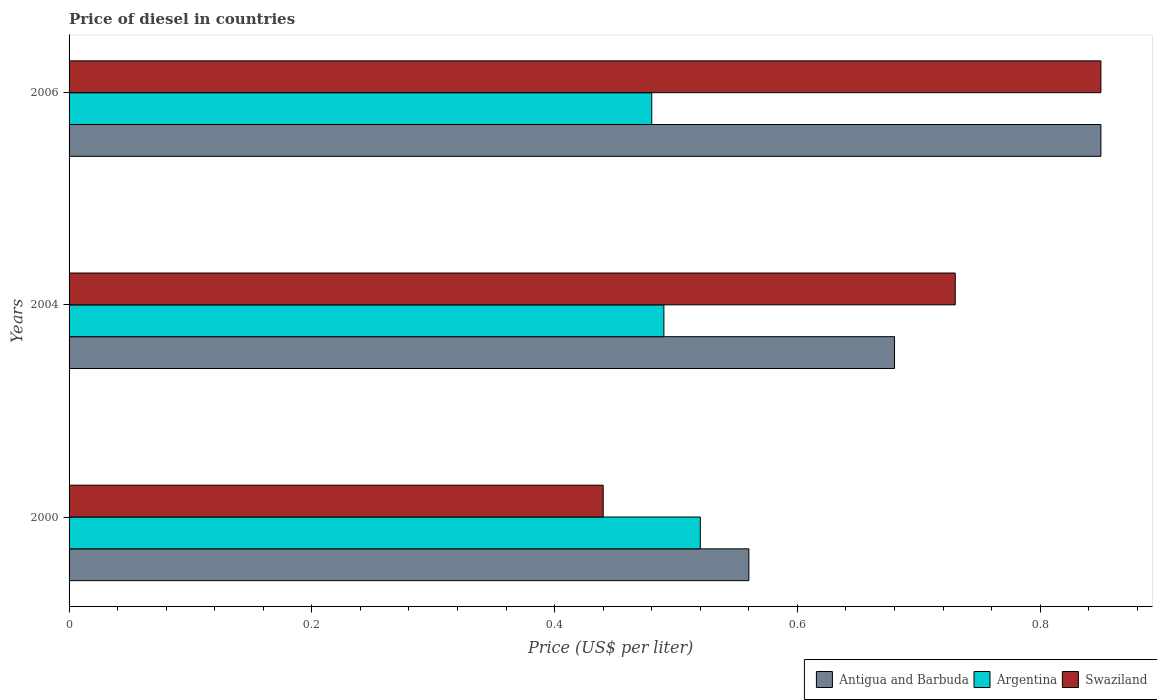How many groups of bars are there?
Provide a succinct answer. 3. Are the number of bars per tick equal to the number of legend labels?
Provide a short and direct response. Yes. How many bars are there on the 1st tick from the top?
Provide a short and direct response. 3. How many bars are there on the 2nd tick from the bottom?
Ensure brevity in your answer.  3. In how many cases, is the number of bars for a given year not equal to the number of legend labels?
Your answer should be very brief. 0. What is the price of diesel in Antigua and Barbuda in 2006?
Offer a very short reply. 0.85. Across all years, what is the maximum price of diesel in Swaziland?
Give a very brief answer. 0.85. Across all years, what is the minimum price of diesel in Antigua and Barbuda?
Offer a very short reply. 0.56. What is the total price of diesel in Antigua and Barbuda in the graph?
Your answer should be compact. 2.09. What is the difference between the price of diesel in Antigua and Barbuda in 2000 and that in 2004?
Keep it short and to the point. -0.12. What is the difference between the price of diesel in Antigua and Barbuda in 2006 and the price of diesel in Argentina in 2000?
Keep it short and to the point. 0.33. What is the average price of diesel in Swaziland per year?
Offer a terse response. 0.67. In the year 2000, what is the difference between the price of diesel in Swaziland and price of diesel in Antigua and Barbuda?
Give a very brief answer. -0.12. In how many years, is the price of diesel in Swaziland greater than 0.8400000000000001 US$?
Keep it short and to the point. 1. What is the ratio of the price of diesel in Swaziland in 2000 to that in 2004?
Give a very brief answer. 0.6. What is the difference between the highest and the second highest price of diesel in Argentina?
Make the answer very short. 0.03. What is the difference between the highest and the lowest price of diesel in Antigua and Barbuda?
Provide a short and direct response. 0.29. Is the sum of the price of diesel in Swaziland in 2004 and 2006 greater than the maximum price of diesel in Antigua and Barbuda across all years?
Offer a very short reply. Yes. What does the 2nd bar from the top in 2006 represents?
Your answer should be very brief. Argentina. What does the 3rd bar from the bottom in 2004 represents?
Give a very brief answer. Swaziland. Are all the bars in the graph horizontal?
Your answer should be compact. Yes. What is the difference between two consecutive major ticks on the X-axis?
Offer a very short reply. 0.2. Does the graph contain any zero values?
Make the answer very short. No. Does the graph contain grids?
Give a very brief answer. No. How many legend labels are there?
Your answer should be compact. 3. What is the title of the graph?
Your answer should be very brief. Price of diesel in countries. Does "Bosnia and Herzegovina" appear as one of the legend labels in the graph?
Your answer should be very brief. No. What is the label or title of the X-axis?
Your answer should be very brief. Price (US$ per liter). What is the Price (US$ per liter) of Antigua and Barbuda in 2000?
Your response must be concise. 0.56. What is the Price (US$ per liter) of Argentina in 2000?
Keep it short and to the point. 0.52. What is the Price (US$ per liter) of Swaziland in 2000?
Give a very brief answer. 0.44. What is the Price (US$ per liter) in Antigua and Barbuda in 2004?
Keep it short and to the point. 0.68. What is the Price (US$ per liter) in Argentina in 2004?
Make the answer very short. 0.49. What is the Price (US$ per liter) in Swaziland in 2004?
Offer a very short reply. 0.73. What is the Price (US$ per liter) in Argentina in 2006?
Your answer should be very brief. 0.48. Across all years, what is the maximum Price (US$ per liter) in Antigua and Barbuda?
Your response must be concise. 0.85. Across all years, what is the maximum Price (US$ per liter) in Argentina?
Ensure brevity in your answer.  0.52. Across all years, what is the maximum Price (US$ per liter) of Swaziland?
Offer a very short reply. 0.85. Across all years, what is the minimum Price (US$ per liter) of Antigua and Barbuda?
Your response must be concise. 0.56. Across all years, what is the minimum Price (US$ per liter) in Argentina?
Provide a short and direct response. 0.48. Across all years, what is the minimum Price (US$ per liter) in Swaziland?
Your response must be concise. 0.44. What is the total Price (US$ per liter) of Antigua and Barbuda in the graph?
Provide a succinct answer. 2.09. What is the total Price (US$ per liter) in Argentina in the graph?
Your answer should be very brief. 1.49. What is the total Price (US$ per liter) in Swaziland in the graph?
Your answer should be very brief. 2.02. What is the difference between the Price (US$ per liter) of Antigua and Barbuda in 2000 and that in 2004?
Keep it short and to the point. -0.12. What is the difference between the Price (US$ per liter) in Swaziland in 2000 and that in 2004?
Give a very brief answer. -0.29. What is the difference between the Price (US$ per liter) in Antigua and Barbuda in 2000 and that in 2006?
Offer a terse response. -0.29. What is the difference between the Price (US$ per liter) in Swaziland in 2000 and that in 2006?
Provide a succinct answer. -0.41. What is the difference between the Price (US$ per liter) in Antigua and Barbuda in 2004 and that in 2006?
Your response must be concise. -0.17. What is the difference between the Price (US$ per liter) in Argentina in 2004 and that in 2006?
Your answer should be very brief. 0.01. What is the difference between the Price (US$ per liter) in Swaziland in 2004 and that in 2006?
Give a very brief answer. -0.12. What is the difference between the Price (US$ per liter) in Antigua and Barbuda in 2000 and the Price (US$ per liter) in Argentina in 2004?
Your answer should be compact. 0.07. What is the difference between the Price (US$ per liter) of Antigua and Barbuda in 2000 and the Price (US$ per liter) of Swaziland in 2004?
Make the answer very short. -0.17. What is the difference between the Price (US$ per liter) in Argentina in 2000 and the Price (US$ per liter) in Swaziland in 2004?
Offer a terse response. -0.21. What is the difference between the Price (US$ per liter) in Antigua and Barbuda in 2000 and the Price (US$ per liter) in Swaziland in 2006?
Provide a succinct answer. -0.29. What is the difference between the Price (US$ per liter) of Argentina in 2000 and the Price (US$ per liter) of Swaziland in 2006?
Provide a succinct answer. -0.33. What is the difference between the Price (US$ per liter) in Antigua and Barbuda in 2004 and the Price (US$ per liter) in Argentina in 2006?
Your answer should be very brief. 0.2. What is the difference between the Price (US$ per liter) of Antigua and Barbuda in 2004 and the Price (US$ per liter) of Swaziland in 2006?
Give a very brief answer. -0.17. What is the difference between the Price (US$ per liter) in Argentina in 2004 and the Price (US$ per liter) in Swaziland in 2006?
Provide a succinct answer. -0.36. What is the average Price (US$ per liter) of Antigua and Barbuda per year?
Provide a succinct answer. 0.7. What is the average Price (US$ per liter) of Argentina per year?
Give a very brief answer. 0.5. What is the average Price (US$ per liter) in Swaziland per year?
Your answer should be compact. 0.67. In the year 2000, what is the difference between the Price (US$ per liter) of Antigua and Barbuda and Price (US$ per liter) of Swaziland?
Offer a very short reply. 0.12. In the year 2004, what is the difference between the Price (US$ per liter) in Antigua and Barbuda and Price (US$ per liter) in Argentina?
Make the answer very short. 0.19. In the year 2004, what is the difference between the Price (US$ per liter) in Antigua and Barbuda and Price (US$ per liter) in Swaziland?
Give a very brief answer. -0.05. In the year 2004, what is the difference between the Price (US$ per liter) in Argentina and Price (US$ per liter) in Swaziland?
Provide a succinct answer. -0.24. In the year 2006, what is the difference between the Price (US$ per liter) in Antigua and Barbuda and Price (US$ per liter) in Argentina?
Provide a short and direct response. 0.37. In the year 2006, what is the difference between the Price (US$ per liter) in Antigua and Barbuda and Price (US$ per liter) in Swaziland?
Make the answer very short. 0. In the year 2006, what is the difference between the Price (US$ per liter) in Argentina and Price (US$ per liter) in Swaziland?
Your answer should be compact. -0.37. What is the ratio of the Price (US$ per liter) in Antigua and Barbuda in 2000 to that in 2004?
Your answer should be very brief. 0.82. What is the ratio of the Price (US$ per liter) in Argentina in 2000 to that in 2004?
Your answer should be very brief. 1.06. What is the ratio of the Price (US$ per liter) of Swaziland in 2000 to that in 2004?
Make the answer very short. 0.6. What is the ratio of the Price (US$ per liter) of Antigua and Barbuda in 2000 to that in 2006?
Your answer should be compact. 0.66. What is the ratio of the Price (US$ per liter) in Argentina in 2000 to that in 2006?
Provide a short and direct response. 1.08. What is the ratio of the Price (US$ per liter) of Swaziland in 2000 to that in 2006?
Your response must be concise. 0.52. What is the ratio of the Price (US$ per liter) in Antigua and Barbuda in 2004 to that in 2006?
Provide a succinct answer. 0.8. What is the ratio of the Price (US$ per liter) in Argentina in 2004 to that in 2006?
Ensure brevity in your answer.  1.02. What is the ratio of the Price (US$ per liter) of Swaziland in 2004 to that in 2006?
Give a very brief answer. 0.86. What is the difference between the highest and the second highest Price (US$ per liter) in Antigua and Barbuda?
Your response must be concise. 0.17. What is the difference between the highest and the second highest Price (US$ per liter) in Swaziland?
Make the answer very short. 0.12. What is the difference between the highest and the lowest Price (US$ per liter) in Antigua and Barbuda?
Provide a short and direct response. 0.29. What is the difference between the highest and the lowest Price (US$ per liter) of Swaziland?
Offer a terse response. 0.41. 